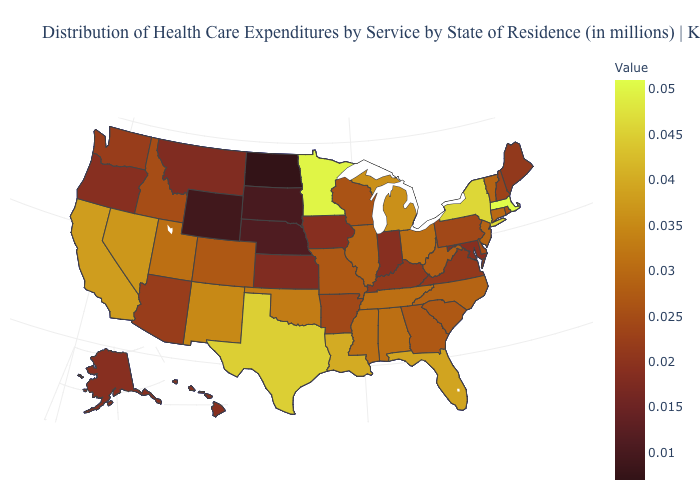Does Kansas have the lowest value in the USA?
Quick response, please. No. Among the states that border Tennessee , which have the highest value?
Concise answer only. Alabama, Mississippi. Which states have the lowest value in the MidWest?
Write a very short answer. North Dakota. Does Idaho have the lowest value in the USA?
Give a very brief answer. No. Which states have the lowest value in the West?
Short answer required. Wyoming. Among the states that border Tennessee , which have the highest value?
Concise answer only. Alabama, Mississippi. Which states have the highest value in the USA?
Concise answer only. Massachusetts. 